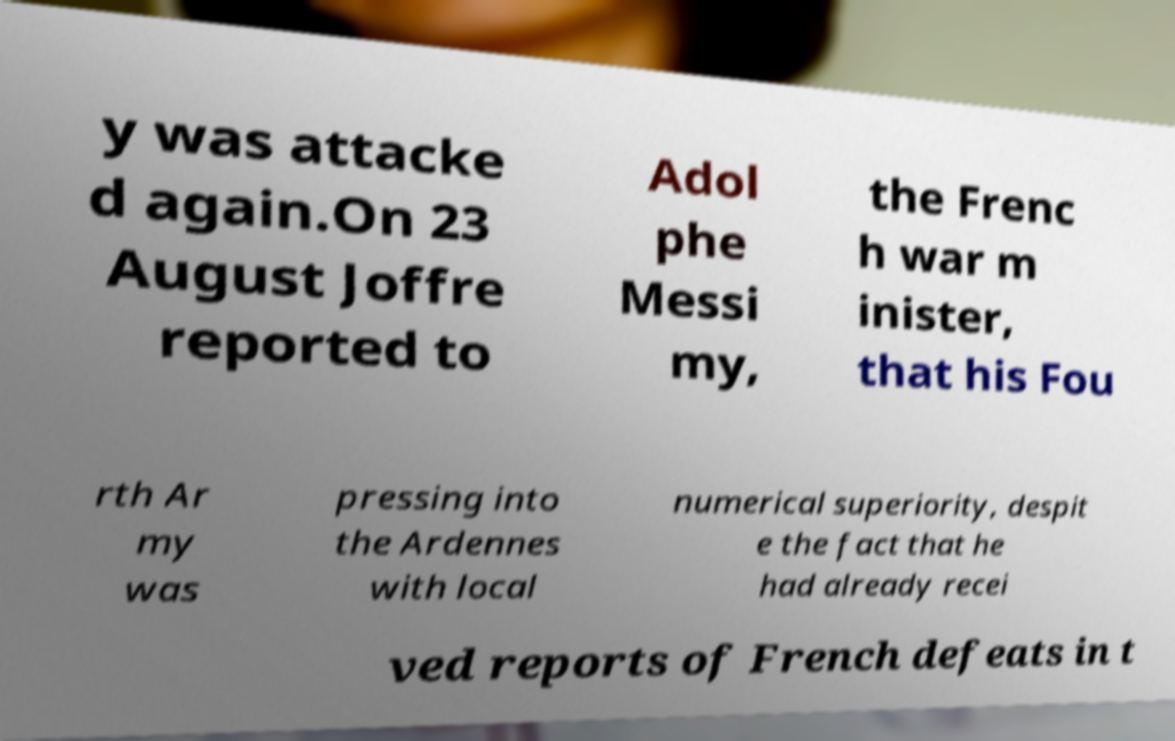Please read and relay the text visible in this image. What does it say? y was attacke d again.On 23 August Joffre reported to Adol phe Messi my, the Frenc h war m inister, that his Fou rth Ar my was pressing into the Ardennes with local numerical superiority, despit e the fact that he had already recei ved reports of French defeats in t 